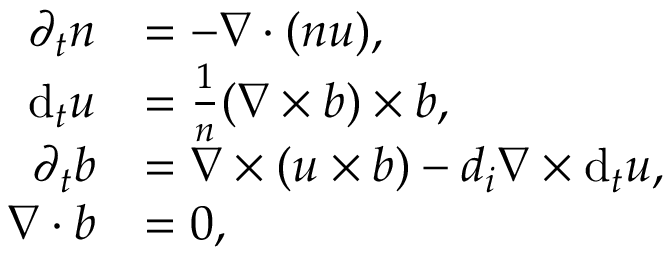Convert formula to latex. <formula><loc_0><loc_0><loc_500><loc_500>\begin{array} { r l } { \partial _ { t } n } & { = - \nabla \cdot ( n u ) , } \\ { d _ { t } u } & { = \frac { 1 } { n } ( \nabla \times b ) \times b , } \\ { \partial _ { t } b } & { = \nabla \times ( u \times b ) - d _ { i } \nabla \times d _ { t } u , } \\ { \nabla \cdot b } & { = 0 , } \end{array}</formula> 